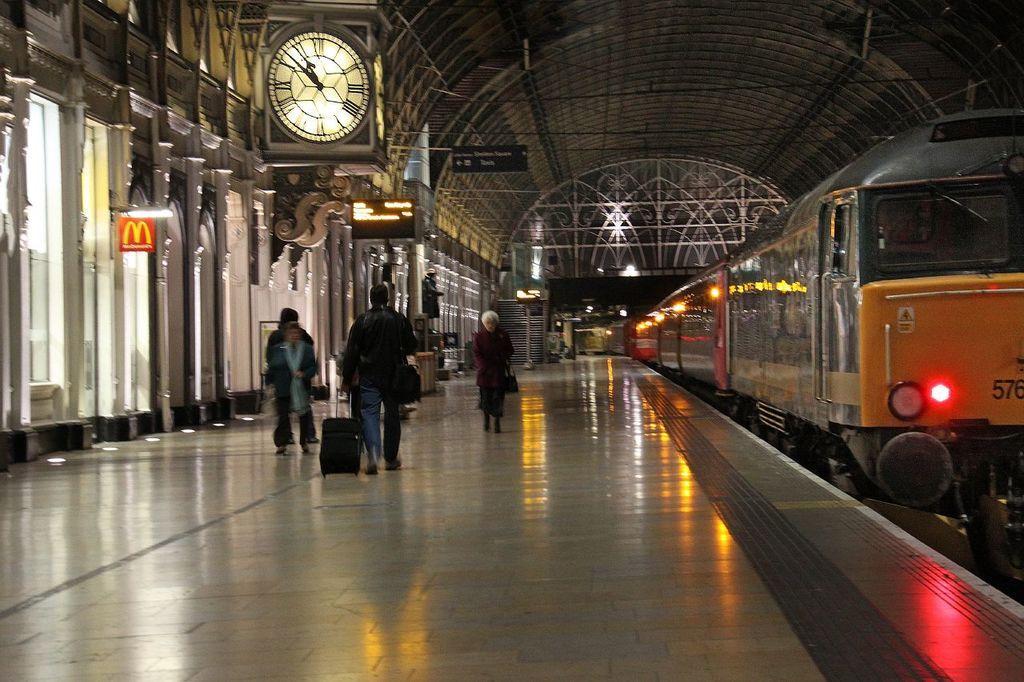Please provide a concise description of this image. In this image, we can see persons in the railway station. There is a clock at the top of the image. There is a train on the right side of the image. 